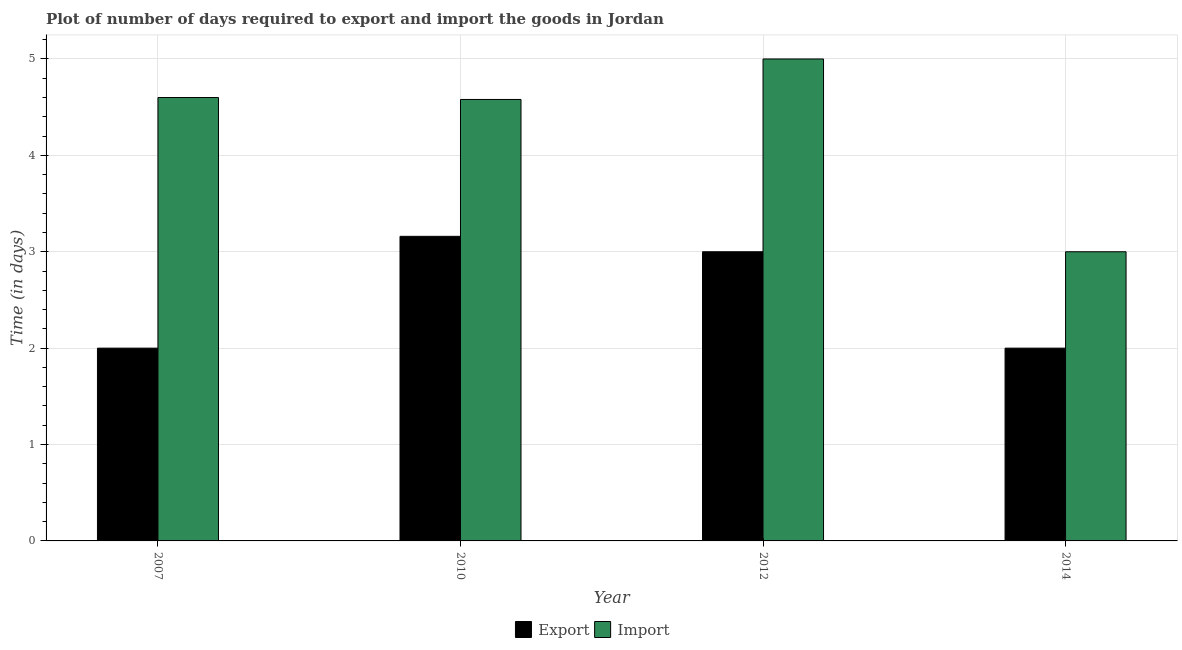How many groups of bars are there?
Provide a short and direct response. 4. Are the number of bars per tick equal to the number of legend labels?
Offer a very short reply. Yes. Are the number of bars on each tick of the X-axis equal?
Give a very brief answer. Yes. How many bars are there on the 4th tick from the left?
Give a very brief answer. 2. What is the time required to import in 2010?
Give a very brief answer. 4.58. Across all years, what is the maximum time required to import?
Give a very brief answer. 5. In which year was the time required to import maximum?
Give a very brief answer. 2012. In which year was the time required to export minimum?
Your answer should be very brief. 2007. What is the total time required to import in the graph?
Ensure brevity in your answer.  17.18. What is the difference between the time required to export in 2007 and that in 2012?
Your response must be concise. -1. What is the difference between the time required to import in 2014 and the time required to export in 2007?
Make the answer very short. -1.6. What is the average time required to export per year?
Your answer should be compact. 2.54. In how many years, is the time required to import greater than 1.6 days?
Your answer should be compact. 4. What is the difference between the highest and the second highest time required to import?
Provide a succinct answer. 0.4. What is the difference between the highest and the lowest time required to export?
Keep it short and to the point. 1.16. What does the 2nd bar from the left in 2010 represents?
Provide a short and direct response. Import. What does the 1st bar from the right in 2014 represents?
Your response must be concise. Import. Are all the bars in the graph horizontal?
Make the answer very short. No. How many years are there in the graph?
Your response must be concise. 4. Does the graph contain any zero values?
Make the answer very short. No. Does the graph contain grids?
Offer a terse response. Yes. Where does the legend appear in the graph?
Make the answer very short. Bottom center. What is the title of the graph?
Provide a succinct answer. Plot of number of days required to export and import the goods in Jordan. What is the label or title of the X-axis?
Your response must be concise. Year. What is the label or title of the Y-axis?
Make the answer very short. Time (in days). What is the Time (in days) in Export in 2007?
Provide a succinct answer. 2. What is the Time (in days) of Import in 2007?
Offer a terse response. 4.6. What is the Time (in days) in Export in 2010?
Offer a terse response. 3.16. What is the Time (in days) of Import in 2010?
Offer a very short reply. 4.58. What is the Time (in days) of Import in 2012?
Your answer should be compact. 5. What is the Time (in days) in Export in 2014?
Offer a very short reply. 2. Across all years, what is the maximum Time (in days) of Export?
Your response must be concise. 3.16. What is the total Time (in days) in Export in the graph?
Your answer should be compact. 10.16. What is the total Time (in days) in Import in the graph?
Provide a succinct answer. 17.18. What is the difference between the Time (in days) in Export in 2007 and that in 2010?
Your answer should be compact. -1.16. What is the difference between the Time (in days) in Export in 2010 and that in 2012?
Ensure brevity in your answer.  0.16. What is the difference between the Time (in days) in Import in 2010 and that in 2012?
Ensure brevity in your answer.  -0.42. What is the difference between the Time (in days) in Export in 2010 and that in 2014?
Your response must be concise. 1.16. What is the difference between the Time (in days) of Import in 2010 and that in 2014?
Provide a succinct answer. 1.58. What is the difference between the Time (in days) in Import in 2012 and that in 2014?
Keep it short and to the point. 2. What is the difference between the Time (in days) in Export in 2007 and the Time (in days) in Import in 2010?
Provide a short and direct response. -2.58. What is the difference between the Time (in days) of Export in 2007 and the Time (in days) of Import in 2012?
Your answer should be compact. -3. What is the difference between the Time (in days) in Export in 2007 and the Time (in days) in Import in 2014?
Your response must be concise. -1. What is the difference between the Time (in days) of Export in 2010 and the Time (in days) of Import in 2012?
Ensure brevity in your answer.  -1.84. What is the difference between the Time (in days) of Export in 2010 and the Time (in days) of Import in 2014?
Provide a short and direct response. 0.16. What is the difference between the Time (in days) in Export in 2012 and the Time (in days) in Import in 2014?
Your response must be concise. 0. What is the average Time (in days) in Export per year?
Offer a very short reply. 2.54. What is the average Time (in days) in Import per year?
Keep it short and to the point. 4.29. In the year 2007, what is the difference between the Time (in days) of Export and Time (in days) of Import?
Ensure brevity in your answer.  -2.6. In the year 2010, what is the difference between the Time (in days) of Export and Time (in days) of Import?
Your response must be concise. -1.42. In the year 2012, what is the difference between the Time (in days) of Export and Time (in days) of Import?
Make the answer very short. -2. In the year 2014, what is the difference between the Time (in days) of Export and Time (in days) of Import?
Ensure brevity in your answer.  -1. What is the ratio of the Time (in days) in Export in 2007 to that in 2010?
Provide a succinct answer. 0.63. What is the ratio of the Time (in days) of Import in 2007 to that in 2010?
Offer a terse response. 1. What is the ratio of the Time (in days) in Export in 2007 to that in 2012?
Provide a succinct answer. 0.67. What is the ratio of the Time (in days) in Export in 2007 to that in 2014?
Provide a short and direct response. 1. What is the ratio of the Time (in days) of Import in 2007 to that in 2014?
Your answer should be very brief. 1.53. What is the ratio of the Time (in days) in Export in 2010 to that in 2012?
Keep it short and to the point. 1.05. What is the ratio of the Time (in days) in Import in 2010 to that in 2012?
Provide a short and direct response. 0.92. What is the ratio of the Time (in days) of Export in 2010 to that in 2014?
Offer a terse response. 1.58. What is the ratio of the Time (in days) of Import in 2010 to that in 2014?
Make the answer very short. 1.53. What is the ratio of the Time (in days) of Import in 2012 to that in 2014?
Offer a very short reply. 1.67. What is the difference between the highest and the second highest Time (in days) in Export?
Your answer should be very brief. 0.16. What is the difference between the highest and the second highest Time (in days) in Import?
Provide a succinct answer. 0.4. What is the difference between the highest and the lowest Time (in days) of Export?
Make the answer very short. 1.16. What is the difference between the highest and the lowest Time (in days) of Import?
Your response must be concise. 2. 